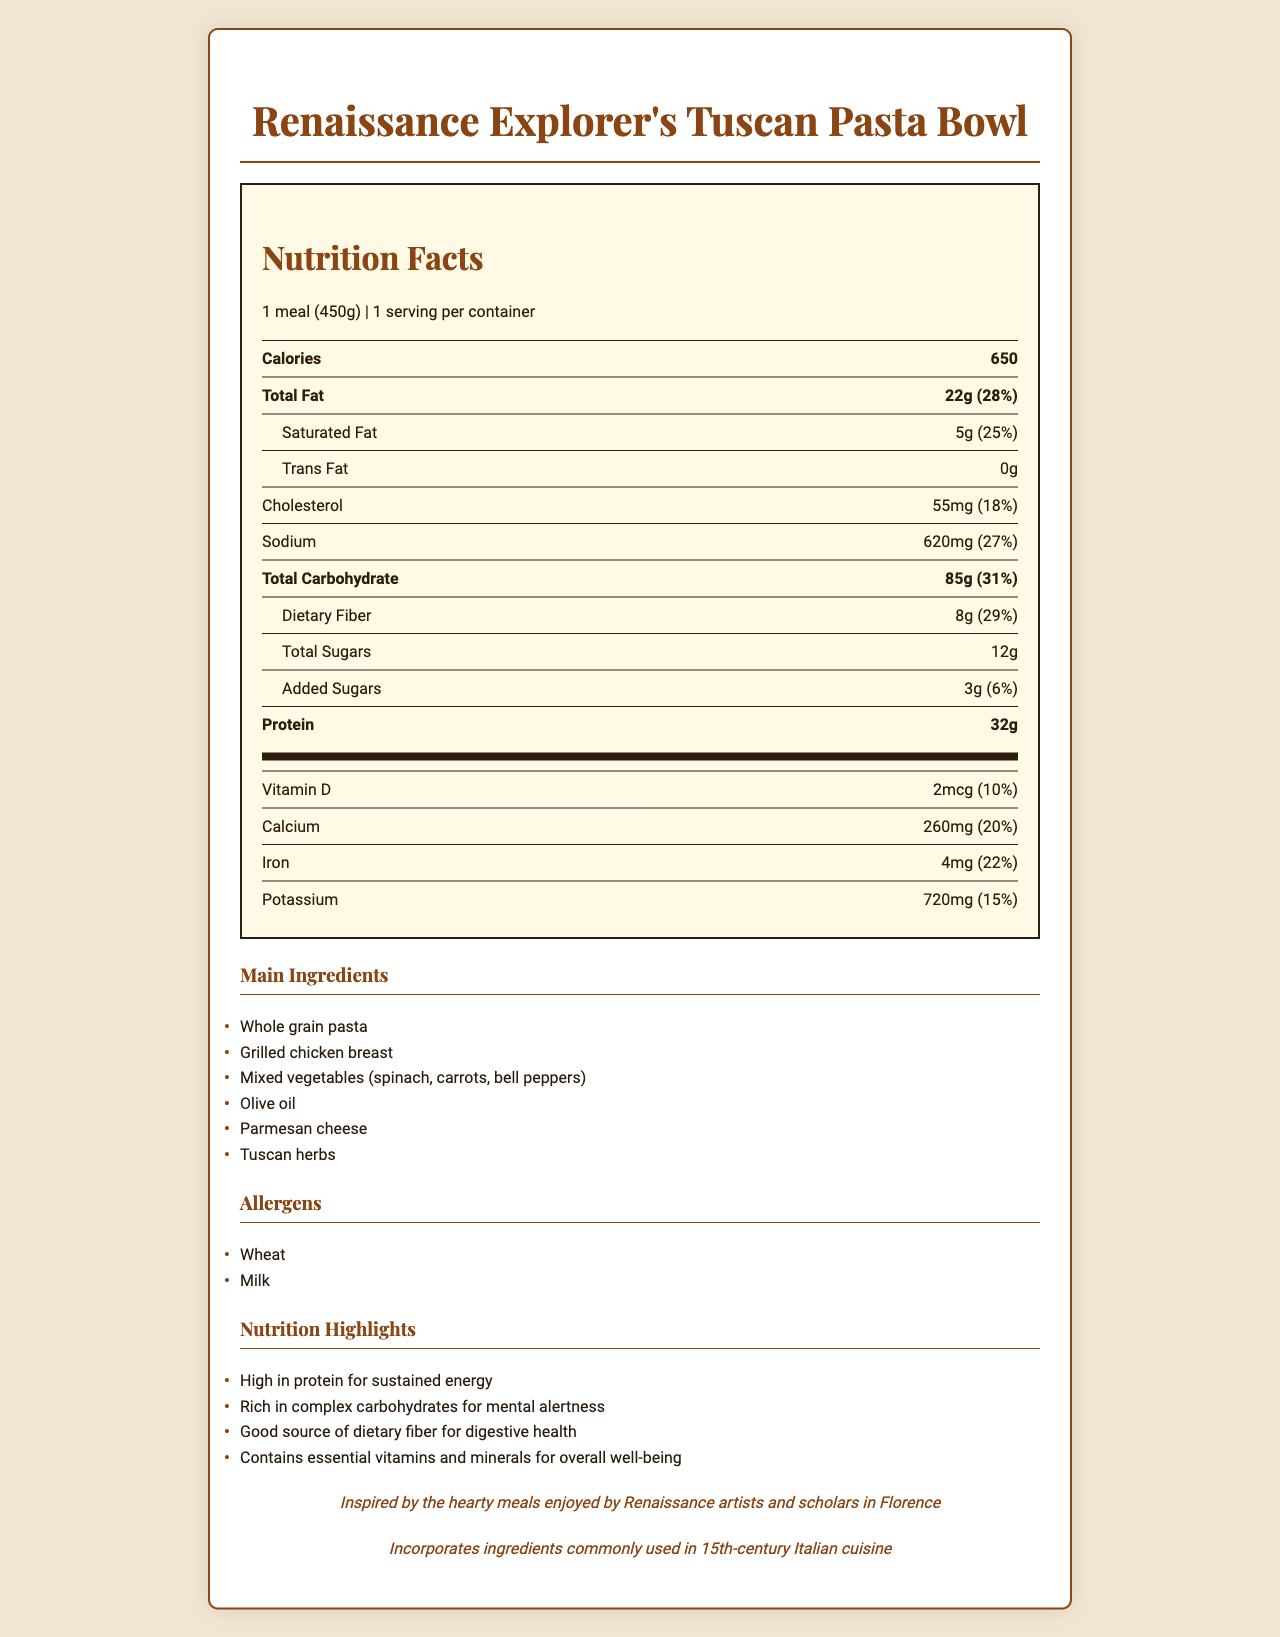what is the serving size of the meal? The serving size is explicitly mentioned as "1 meal (450g)" in the document.
Answer: 1 meal (450g) how many calories are in one serving? The calories are listed directly in the nutrition facts section as 650.
Answer: 650 what percentage of daily value is the total fat? The total fat daily value percentage is listed as 28% next to the corresponding amount.
Answer: 28% which vitamins and minerals are included in the nutrition facts? Vitamin D, Calcium, Iron, and Potassium are listed in the nutrition facts with their amounts and daily values.
Answer: Vitamin D, Calcium, Iron, Potassium what are the allergens present in the meal? The allergens are listed in a dedicated section as Wheat and Milk.
Answer: Wheat, Milk how much protein is in the meal? The amount of protein is listed as 32g in the nutrition facts section.
Answer: 32g what is the purpose of high protein content in the meal? A. For mental alertness B. For digestive health C. For sustained energy D. For overall well-being The nutrition highlights mention that high protein content is included for sustained energy.
Answer: C. For sustained energy what ingredients make up the meal? A. Whole grain pasta, Grilled chicken breast, Mixed vegetables B. Rice, Tofu, Spices C. Potatoes, Beef, Cheese The main ingredients are listed as Whole grain pasta, Grilled chicken breast, and Mixed vegetables.
Answer: A. Whole grain pasta, Grilled chicken breast, Mixed vegetables is this meal suitable for someone with a peanut allergy? Peanuts are not listed as an allergen in the meal, so it is suitable for someone with a peanut allergy.
Answer: Yes describe the main idea of the document. The document serves to inform about the nutritional content and health benefits of the meal tailored for a day's outing to explore Renaissance culture. It also ties the meal to historical and cultural contexts.
Answer: The document provides a detailed nutrition facts label for the "Renaissance Explorer's Tuscan Pasta Bowl" meal. It includes serving size, calories, amounts and daily values for fats, cholesterol, sodium, carbohydrates, sugars, protein, vitamins, and minerals. The document also lists ingredients, allergens, and highlights the nutritional benefits of the meal. There's a historical context note about the meal's inspiration and a mention of using sustainable ingredients. how much iron is in the meal? The nutrition facts state that the meal contains 4mg of iron.
Answer: 4mg what is the historical context mentioned in the document? The historical note mentions that the meal is inspired by what Renaissance artists and scholars in Florence would have eaten.
Answer: Inspired by the hearty meals enjoyed by Renaissance artists and scholars in Florence what is the total amount of sugars in the meal? The document lists the total sugars as 12g.
Answer: 12g is there any trans fat in the meal? The document states that the amount of trans fat is 0g.
Answer: No does the meal include any locally sourced ingredients? The document mentions that it includes locally sourced vegetables.
Answer: Yes what is the document about? The question is too broad and does not specify what aspect of the document it is asking about. The document contains multiple sections, including nutritional facts, ingredients, and historical context, making it difficult to provide a concise, single answer.
Answer: Cannot be determined 